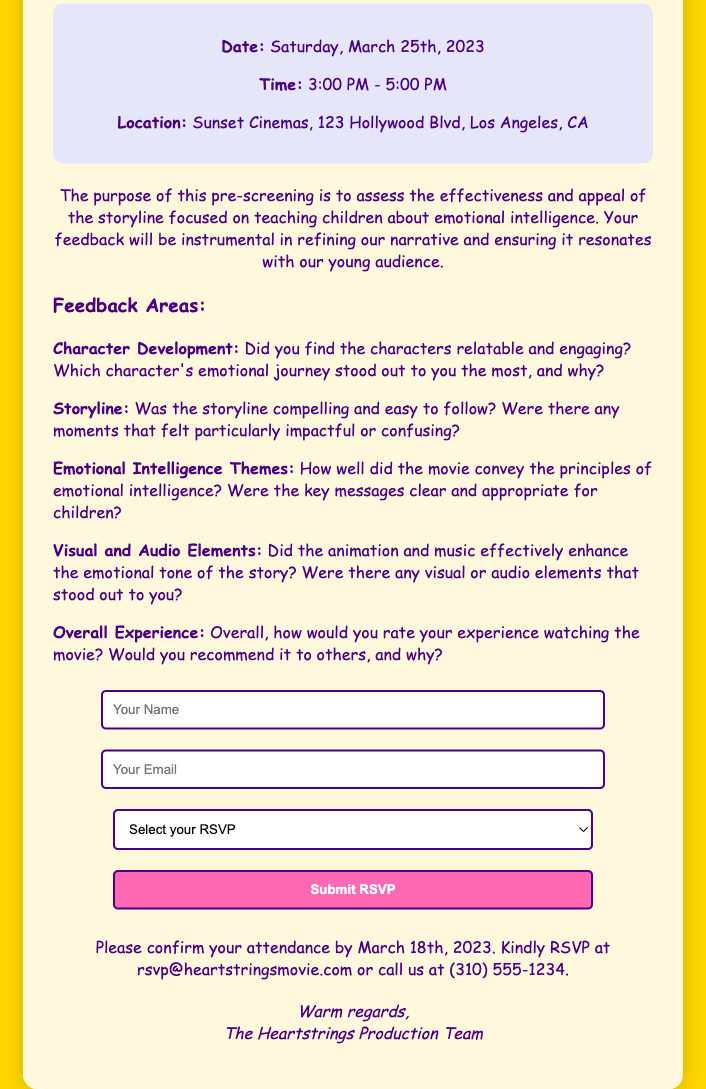What is the title of the movie? The title of the movie as stated in the document is 'Heartstrings: Journey to Emotional Intelligence'.
Answer: 'Heartstrings: Journey to Emotional Intelligence' What is the date of the pre-screening? The document specifies the date of the pre-screening event, which is Saturday, March 25th, 2023.
Answer: Saturday, March 25th, 2023 Where is the location of the event? The location of the pre-screening is mentioned in the document as Sunset Cinemas, 123 Hollywood Blvd, Los Angeles, CA.
Answer: Sunset Cinemas, 123 Hollywood Blvd, Los Angeles, CA What time does the event start? The document indicates that the pre-screening begins at 3:00 PM.
Answer: 3:00 PM What should attendees confirm by March 18th, 2023? The document requests confirmation of attendance, which includes RSVP details by a specified date.
Answer: Attendance What is one of the feedback areas mentioned? The document lists several feedback areas, and one of them is 'Character Development'.
Answer: Character Development What is the email address for RSVPs? The document provides the email address for RSVPs, which is rsvp@heartstringsmovie.com.
Answer: rsvp@heartstringsmovie.com How many feedback items are there in total? The document outlines five distinct feedback items that the producers are interested in.
Answer: Five What is the color of the card's background? The document describes the background color of the card as #FFD700.
Answer: #FFD700 What is the overall purpose of the pre-screening? According to the document, the purpose of the pre-screening is to assess the effectiveness and appeal of the storyline.
Answer: Assess effectiveness and appeal 